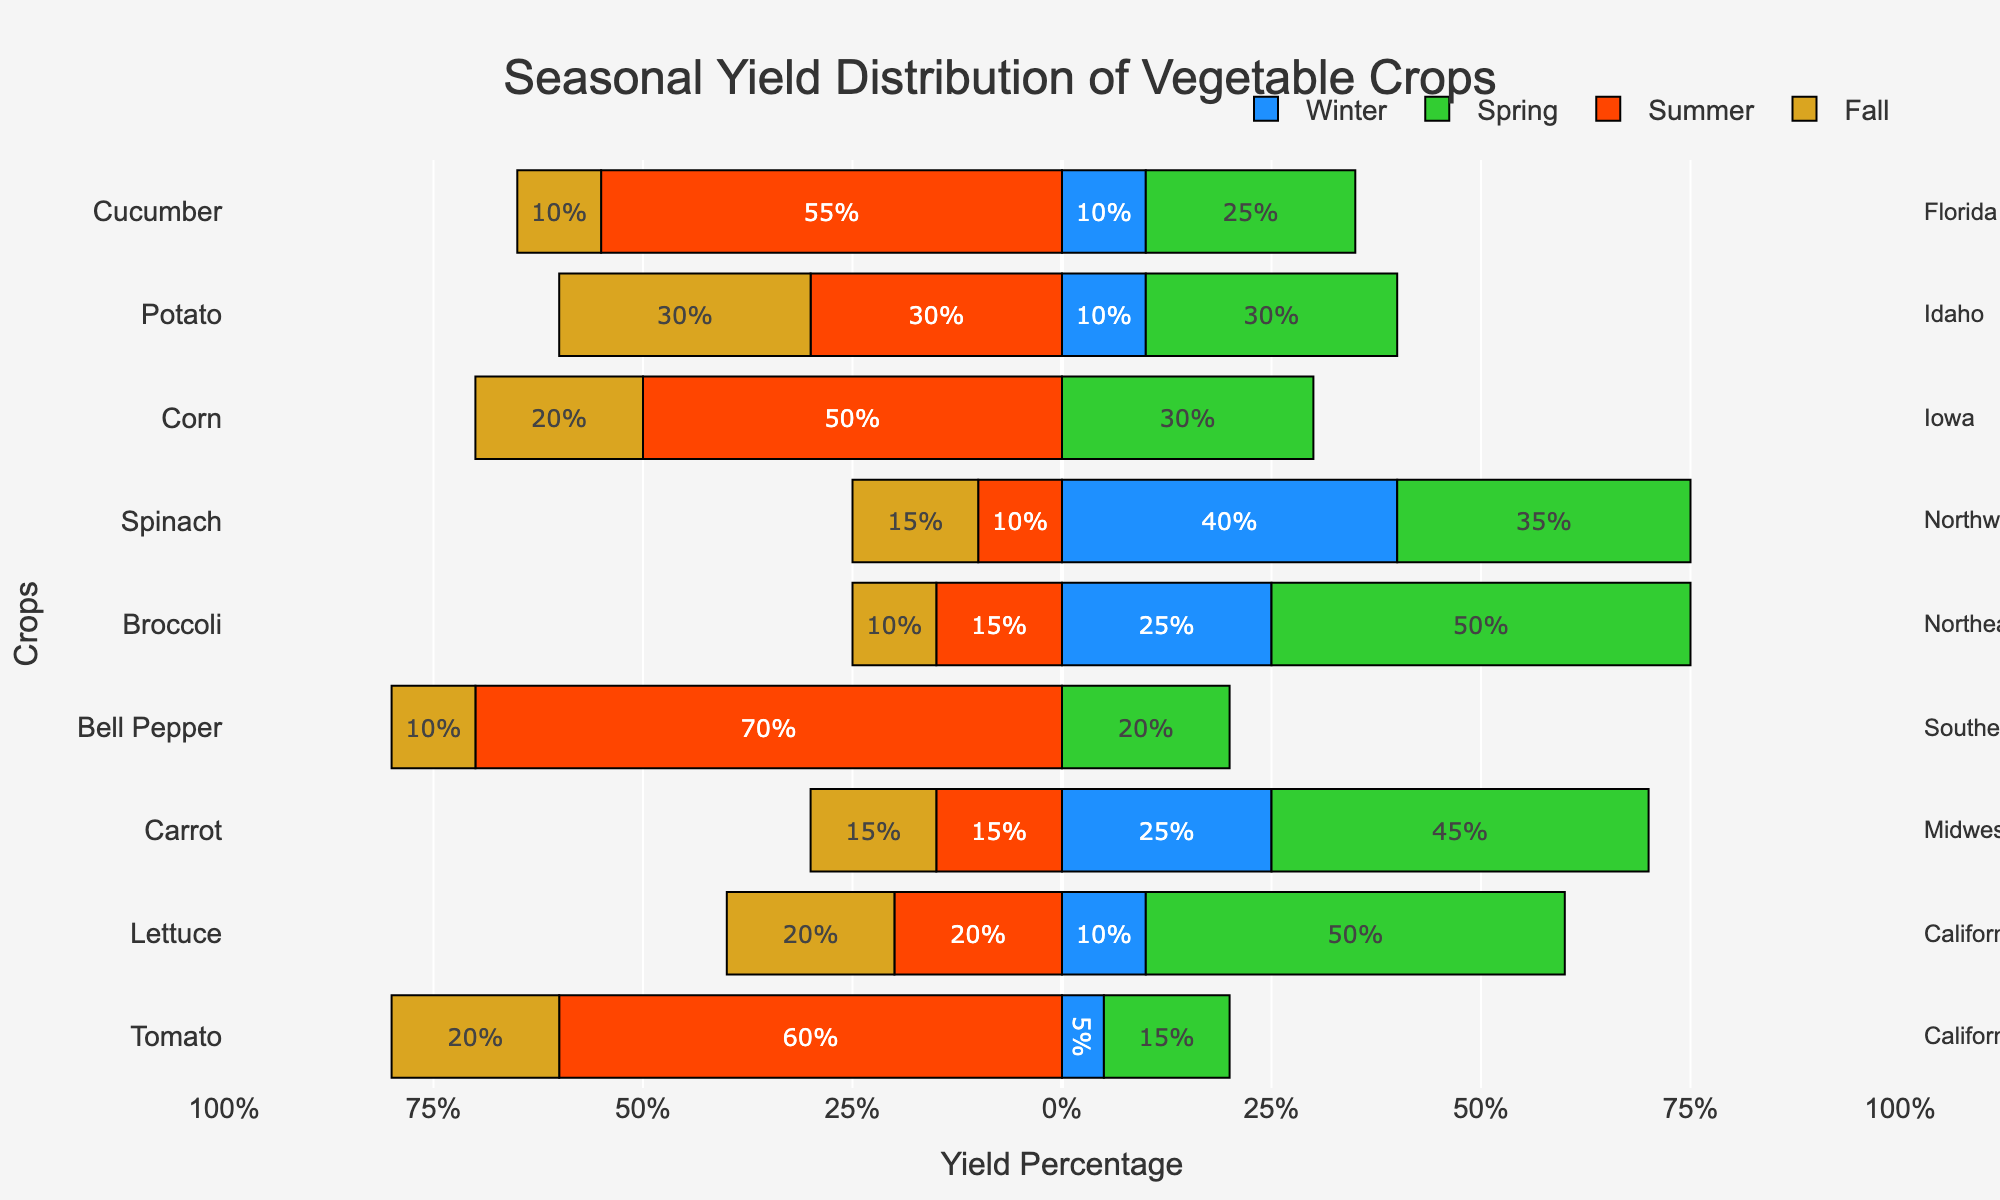What crop has the highest summer yield percentage, and what is the specific value? The figure shows bars for each crop with their respective yields for different seasons. The longest negatively directed bar among the summer section corresponds to Bell Pepper, which extends the farthest. Referring to this, Bell Pepper has the highest summer yield of 70%.
Answer: Bell Pepper, 70% Which season shows the most uniform yield distribution for Lettuce? For Lettuce, the lengths of the bars for each season give a clear indication. The spring yield bar for Lettuce is significantly longer and prominent compared to others, showing a consistent and substantial yield.
Answer: Spring What is the total combined yield for Spinach across all seasons? Sum the yields of Spinach for all seasons from the figure: Winter (40%) + Spring (35%) + Summer (10%) + Fall (15%) = 100%.
Answer: 100% Compare the spring yields of Broccoli and Carrot. Which crop has a higher yield and by how much? By comparing the lengths of the Spring section bars for Broccoli and Carrot, it is clear that Broccoli's bar is longer. Broccoli has a yield of 50%, while Carrot has 45%. The difference is 50% - 45% = 5%.
Answer: Broccoli, 5% Which crop has the highest fall yield and what is the value? By examining the fall yield bars, focus on the longest among them. The crop with the longest fall yield bar is Potato, with a yield of 30%.
Answer: Potato, 30% What is unique about Corn's seasonal yield distribution when compared to other crops? By reviewing the bars for each crop in Corn's row, Corn has a significant yield in both spring and summer without any yield listed for winter. This is different from other crops which typically spread yields across all seasons.
Answer: No winter yield with high spring and summer yields How does the winter yield of Tomato compare to that of Broccoli? Compare the Winter yield bars for both crops. The Tomato's winter yield bar is shorter than Broccoli's. Tomato has a winter yield of 5%, while Broccoli has 25%.
Answer: Broccoli has a higher winter yield by 20% Which crop in the Southeast region has an exceptionally high summer yield? In the figure, the Southeast region is represented by Bell Pepper. Its summer yield bar is significantly higher than others' in the same region. This signifies an exceptionally high summer yield.
Answer: Bell Pepper What is the average yield of Potato across all seasons? Sum the yields for Potato and divide by the number of seasons: (10% + 30% + 30% + 30%) / 4 = 100% / 4 = 25%.
Answer: 25% 